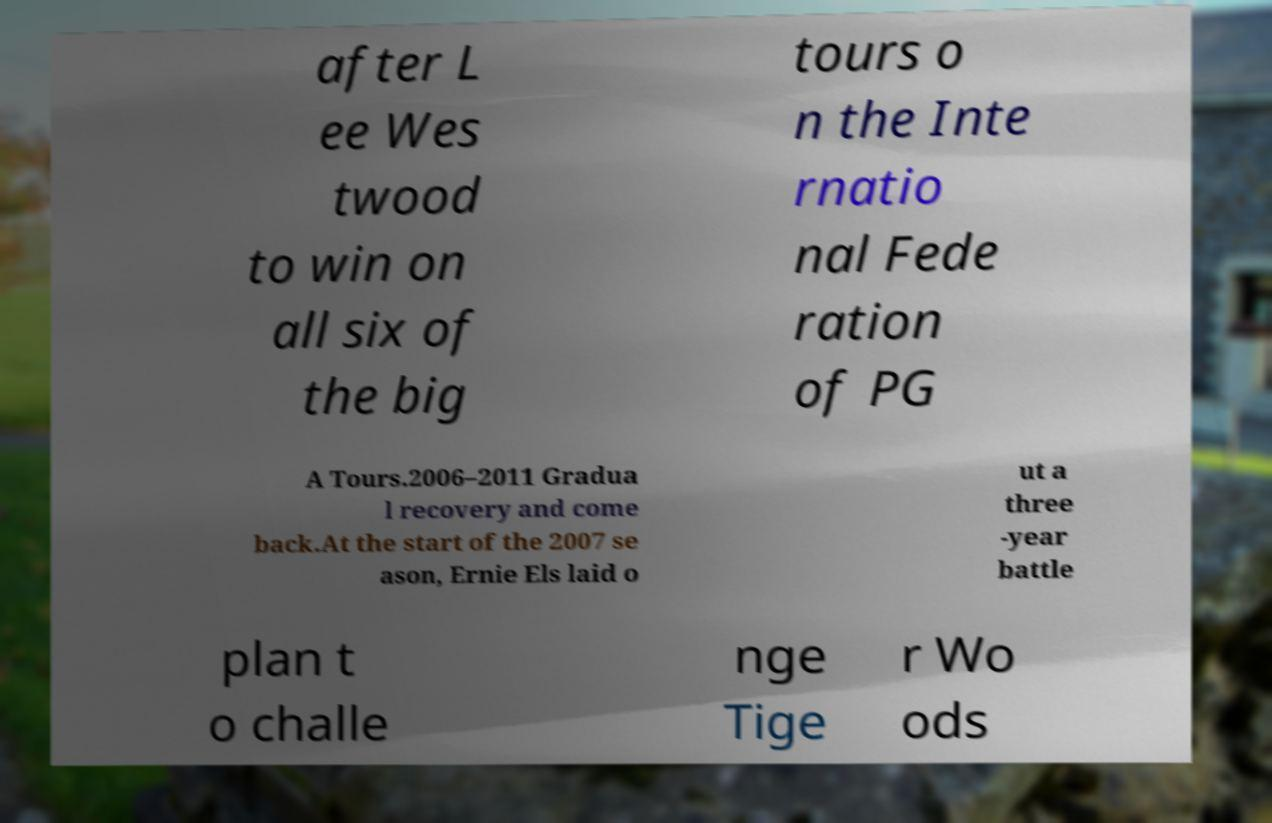Could you extract and type out the text from this image? after L ee Wes twood to win on all six of the big tours o n the Inte rnatio nal Fede ration of PG A Tours.2006–2011 Gradua l recovery and come back.At the start of the 2007 se ason, Ernie Els laid o ut a three -year battle plan t o challe nge Tige r Wo ods 